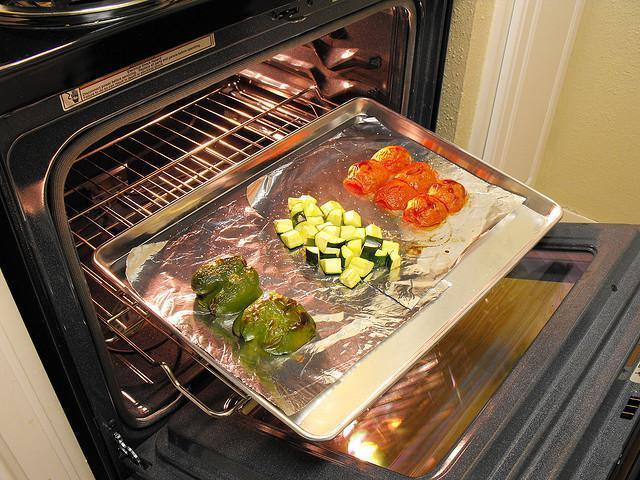How many different types of vegetables are there shown?
Give a very brief answer. 3. How many tomato slices?
Give a very brief answer. 6. 